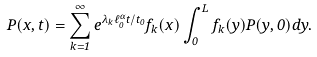<formula> <loc_0><loc_0><loc_500><loc_500>P ( x , t ) = \sum _ { k = 1 } ^ { \infty } e ^ { \lambda _ { k } \ell _ { 0 } ^ { \alpha } t / t _ { 0 } } f _ { k } ( x ) \int _ { 0 } ^ { L } f _ { k } ( y ) P ( y , 0 ) d y .</formula> 